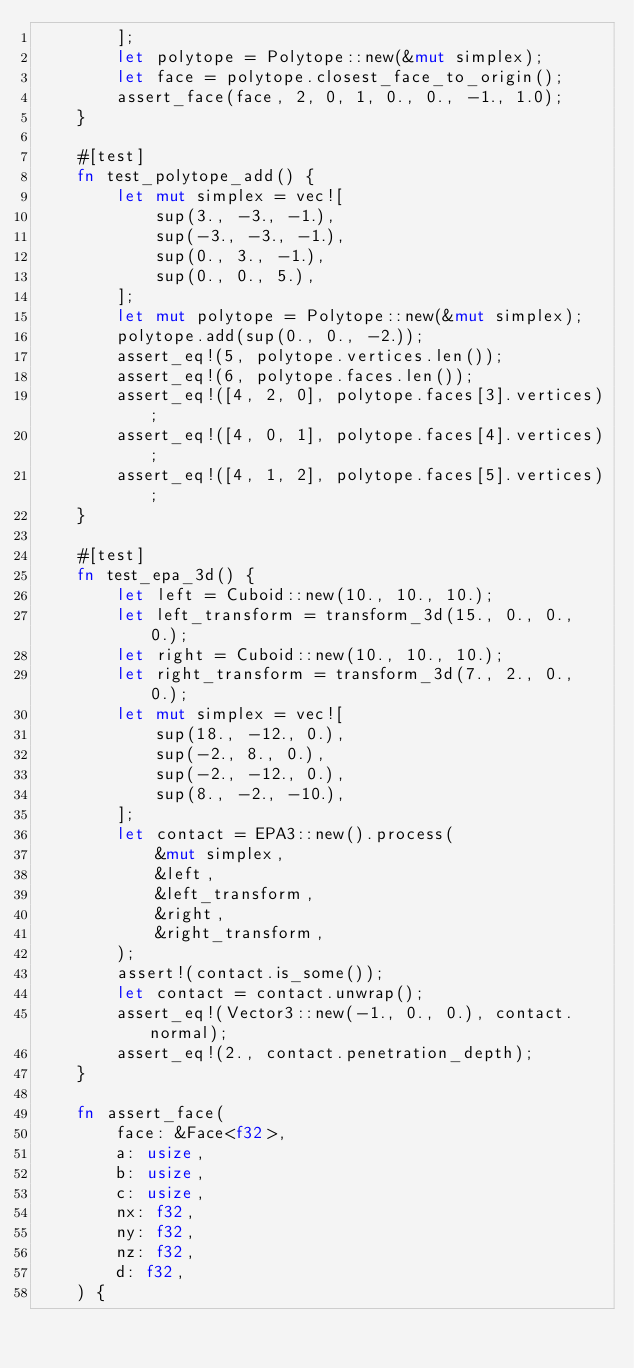Convert code to text. <code><loc_0><loc_0><loc_500><loc_500><_Rust_>        ];
        let polytope = Polytope::new(&mut simplex);
        let face = polytope.closest_face_to_origin();
        assert_face(face, 2, 0, 1, 0., 0., -1., 1.0);
    }

    #[test]
    fn test_polytope_add() {
        let mut simplex = vec![
            sup(3., -3., -1.),
            sup(-3., -3., -1.),
            sup(0., 3., -1.),
            sup(0., 0., 5.),
        ];
        let mut polytope = Polytope::new(&mut simplex);
        polytope.add(sup(0., 0., -2.));
        assert_eq!(5, polytope.vertices.len());
        assert_eq!(6, polytope.faces.len());
        assert_eq!([4, 2, 0], polytope.faces[3].vertices);
        assert_eq!([4, 0, 1], polytope.faces[4].vertices);
        assert_eq!([4, 1, 2], polytope.faces[5].vertices);
    }

    #[test]
    fn test_epa_3d() {
        let left = Cuboid::new(10., 10., 10.);
        let left_transform = transform_3d(15., 0., 0., 0.);
        let right = Cuboid::new(10., 10., 10.);
        let right_transform = transform_3d(7., 2., 0., 0.);
        let mut simplex = vec![
            sup(18., -12., 0.),
            sup(-2., 8., 0.),
            sup(-2., -12., 0.),
            sup(8., -2., -10.),
        ];
        let contact = EPA3::new().process(
            &mut simplex,
            &left,
            &left_transform,
            &right,
            &right_transform,
        );
        assert!(contact.is_some());
        let contact = contact.unwrap();
        assert_eq!(Vector3::new(-1., 0., 0.), contact.normal);
        assert_eq!(2., contact.penetration_depth);
    }

    fn assert_face(
        face: &Face<f32>,
        a: usize,
        b: usize,
        c: usize,
        nx: f32,
        ny: f32,
        nz: f32,
        d: f32,
    ) {</code> 